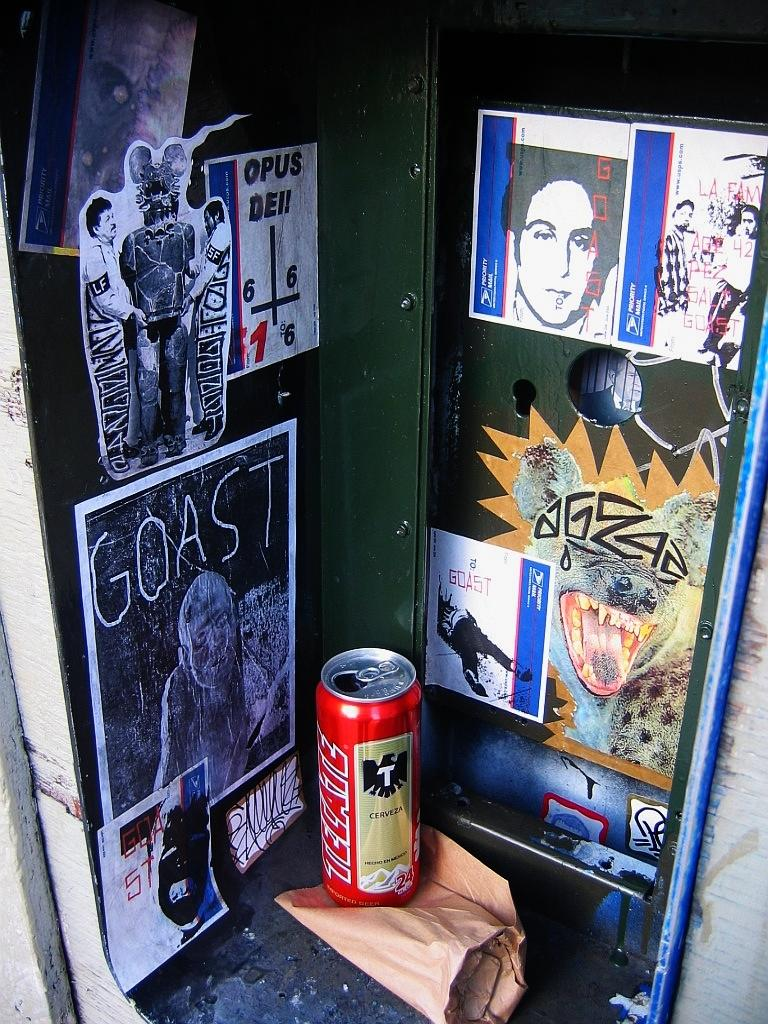Provide a one-sentence caption for the provided image. An open can of Tecate beer sits by various stickers and posters. 